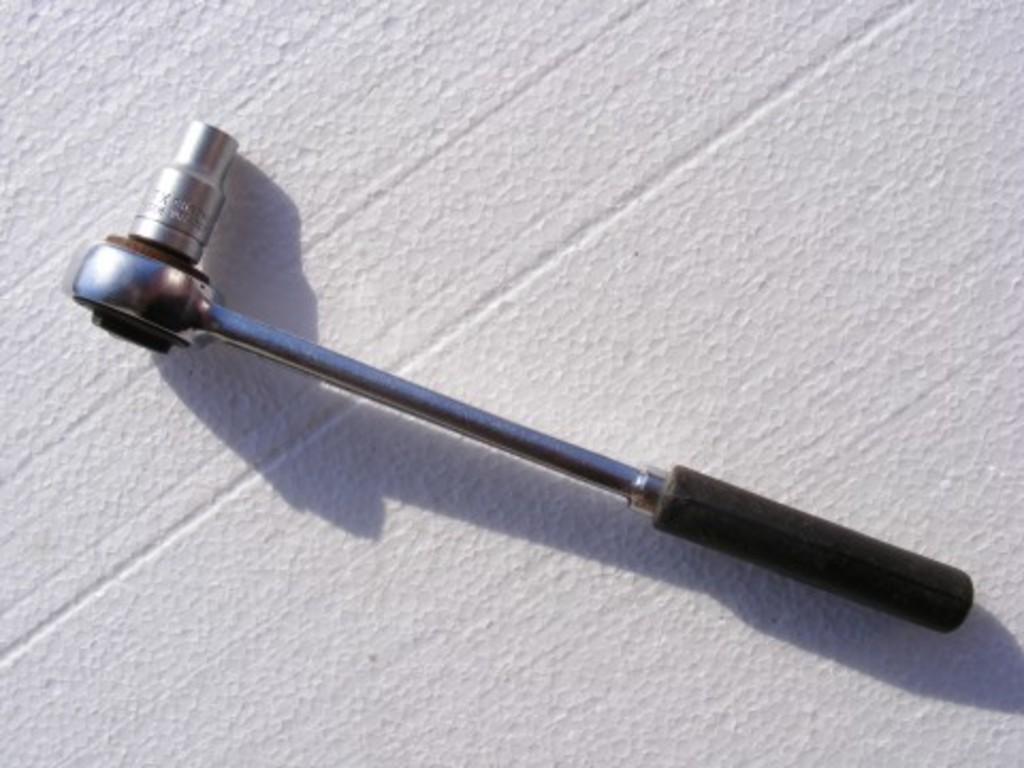In one or two sentences, can you explain what this image depicts? In the picture we can see a white color surface on it we can see some tool with black color handle. 